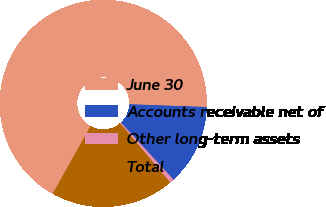<chart> <loc_0><loc_0><loc_500><loc_500><pie_chart><fcel>June 30<fcel>Accounts receivable net of<fcel>Other long-term assets<fcel>Total<nl><fcel>67.45%<fcel>12.6%<fcel>0.67%<fcel>19.28%<nl></chart> 